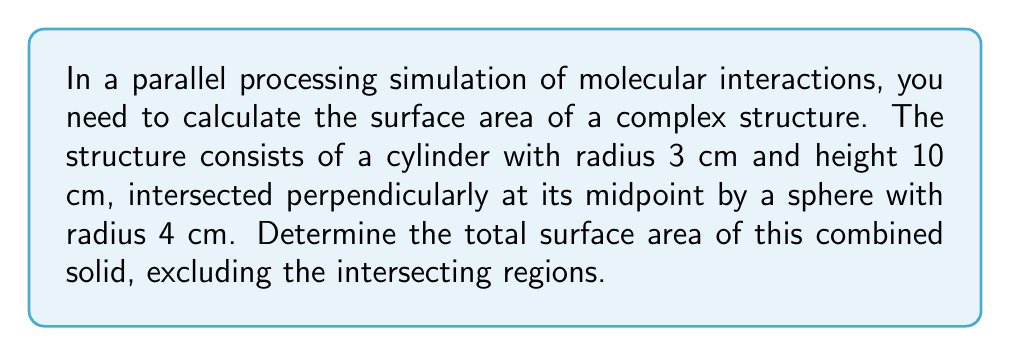Help me with this question. Let's approach this step-by-step:

1) First, we need to calculate the surface areas of the individual solids:

   a) For the cylinder:
      Lateral surface area: $A_l = 2\pi rh = 2\pi \cdot 3 \cdot 10 = 60\pi$ cm²
      Top and bottom circular areas: $A_c = 2\pi r^2 = 2\pi \cdot 3^2 = 18\pi$ cm²
      Total cylinder surface area: $A_{cyl} = 78\pi$ cm²

   b) For the sphere:
      Surface area: $A_{sph} = 4\pi r^2 = 4\pi \cdot 4^2 = 64\pi$ cm²

2) Now, we need to subtract the intersecting areas:

   a) The intersection forms two circular regions on the cylinder:
      Area of one circular intersection: $A_i = \pi r^2 = \pi \cdot 3^2 = 9\pi$ cm²
      Total intersection area on cylinder: $2 \cdot 9\pi = 18\pi$ cm²

   b) The same area needs to be subtracted from the sphere's surface area

3) Calculate the final surface area:

   $A_{total} = A_{cyl} + A_{sph} - 2A_i$
   $A_{total} = 78\pi + 64\pi - 2(18\pi)$
   $A_{total} = 142\pi - 36\pi = 106\pi$ cm²

Therefore, the total surface area of the combined solid is $106\pi$ cm².
Answer: $106\pi$ cm² 